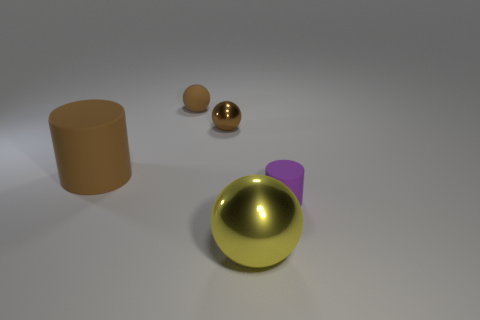How many other objects are there of the same shape as the purple thing?
Your response must be concise. 1. Does the purple rubber cylinder have the same size as the matte sphere?
Offer a very short reply. Yes. What number of tiny things are either yellow blocks or brown balls?
Provide a short and direct response. 2. What number of yellow balls are in front of the purple rubber thing?
Make the answer very short. 1. Is the number of yellow shiny objects to the right of the big yellow ball greater than the number of brown shiny things?
Keep it short and to the point. No. What is the shape of the large thing that is the same material as the purple cylinder?
Your answer should be very brief. Cylinder. The tiny metal object behind the big object that is in front of the small rubber cylinder is what color?
Offer a very short reply. Brown. Does the small purple object have the same shape as the big yellow metallic thing?
Offer a very short reply. No. What material is the other purple object that is the same shape as the big rubber thing?
Provide a succinct answer. Rubber. Is there a large yellow thing behind the brown matte object right of the cylinder left of the small purple thing?
Ensure brevity in your answer.  No. 